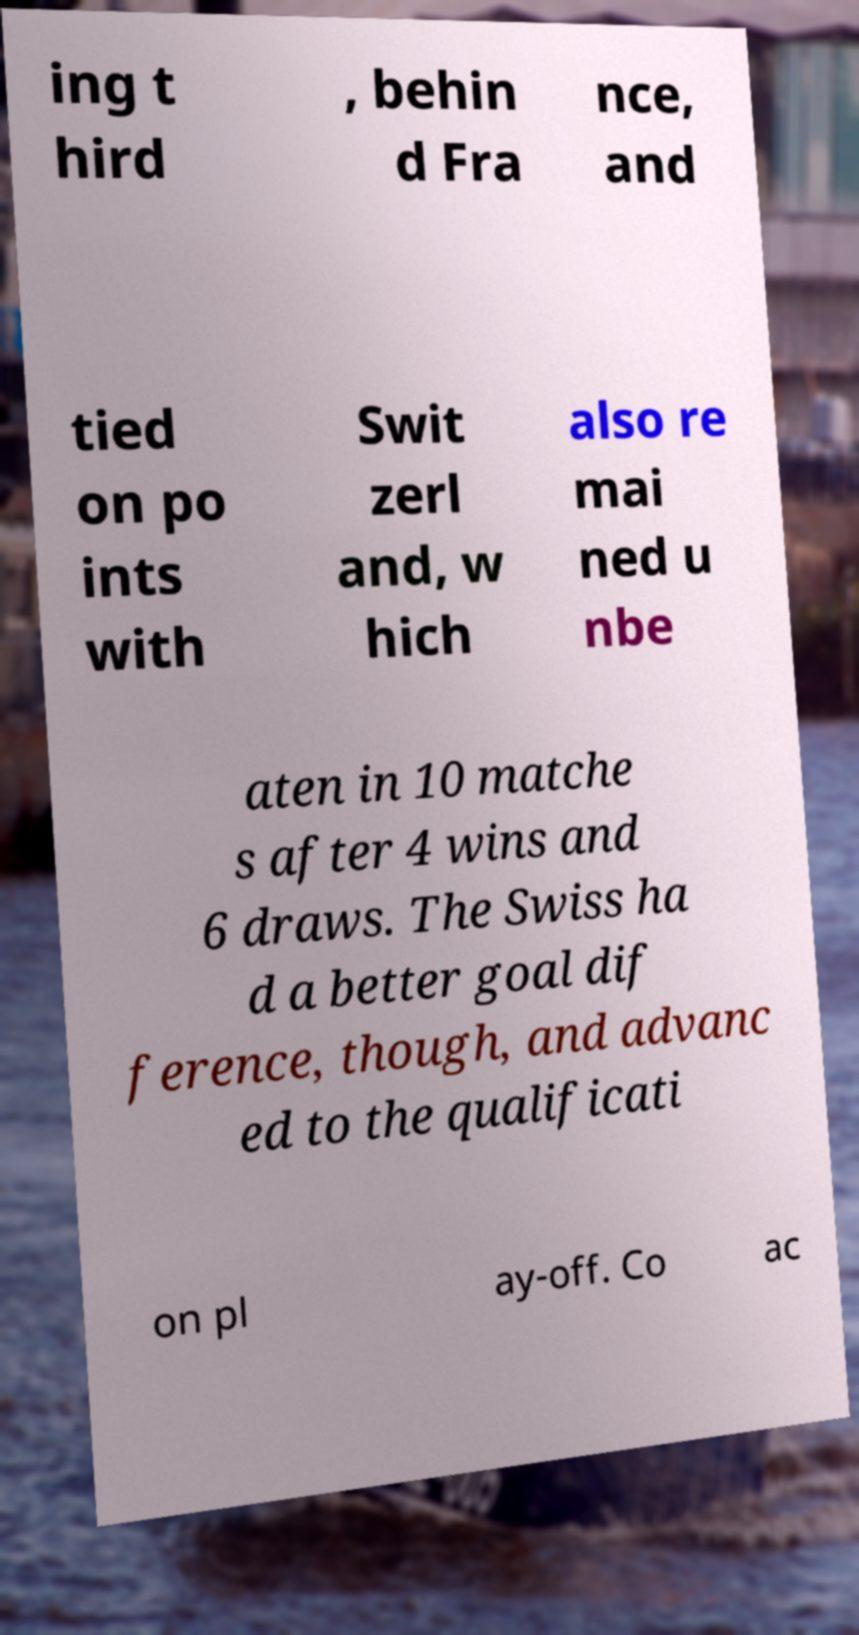For documentation purposes, I need the text within this image transcribed. Could you provide that? ing t hird , behin d Fra nce, and tied on po ints with Swit zerl and, w hich also re mai ned u nbe aten in 10 matche s after 4 wins and 6 draws. The Swiss ha d a better goal dif ference, though, and advanc ed to the qualificati on pl ay-off. Co ac 